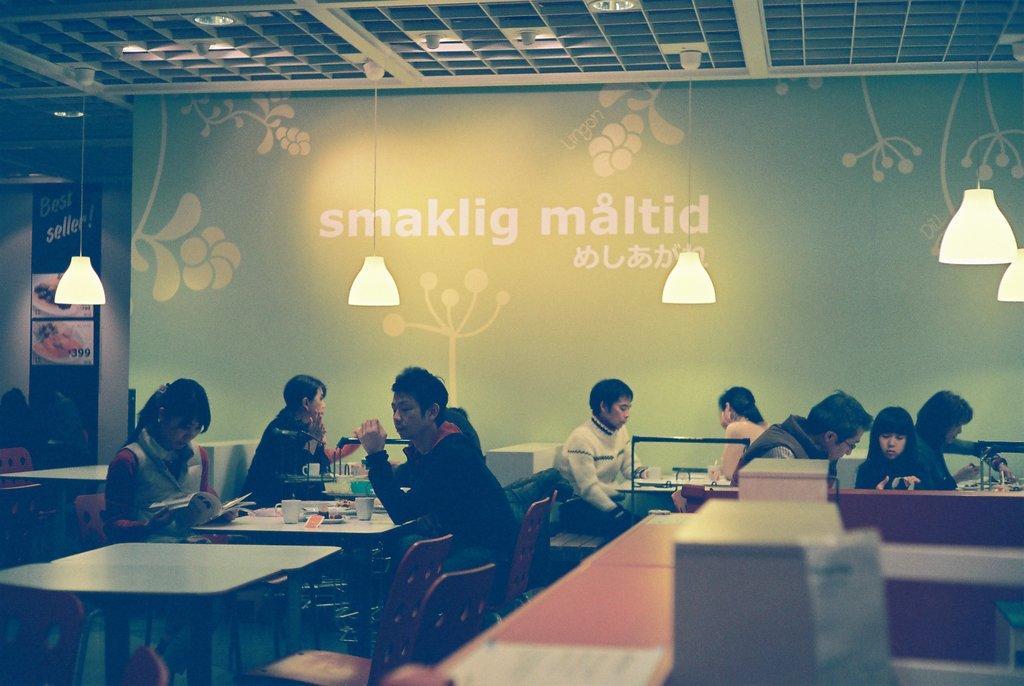How would you summarize this image in a sentence or two? In this image I can see number of people are sitting on chairs. I can also see few tables and on these tables I can see few cups. Here I can see few lights and a painting on this wall. 